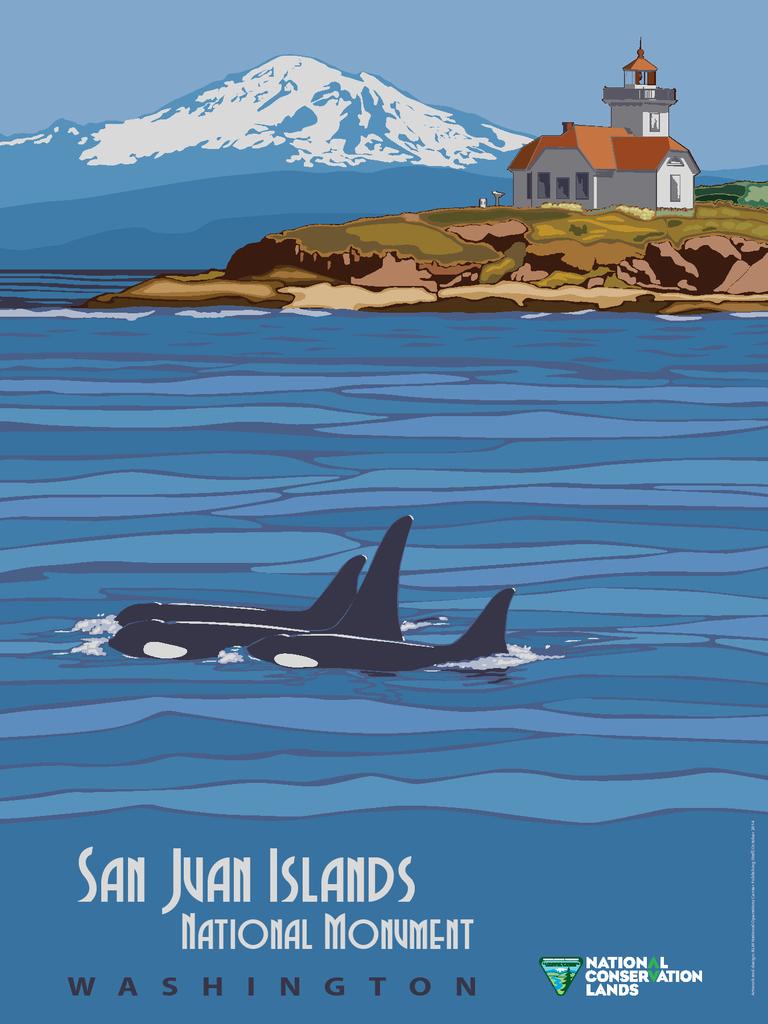What is the name of the islands?
Make the answer very short. San juan. What state is the monument in?
Your response must be concise. Washington. 